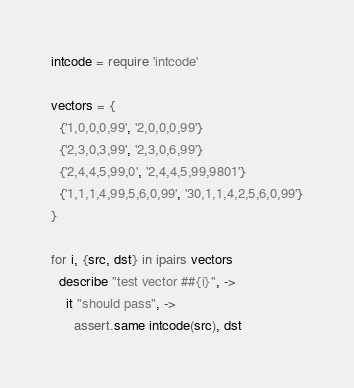Convert code to text. <code><loc_0><loc_0><loc_500><loc_500><_MoonScript_>intcode = require 'intcode'

vectors = {
  {'1,0,0,0,99', '2,0,0,0,99'}
  {'2,3,0,3,99', '2,3,0,6,99'}
  {'2,4,4,5,99,0', '2,4,4,5,99,9801'}
  {'1,1,1,4,99,5,6,0,99', '30,1,1,4,2,5,6,0,99'}
}

for i, {src, dst} in ipairs vectors
  describe "test vector ##{i}", ->
    it "should pass", ->
      assert.same intcode(src), dst
</code> 